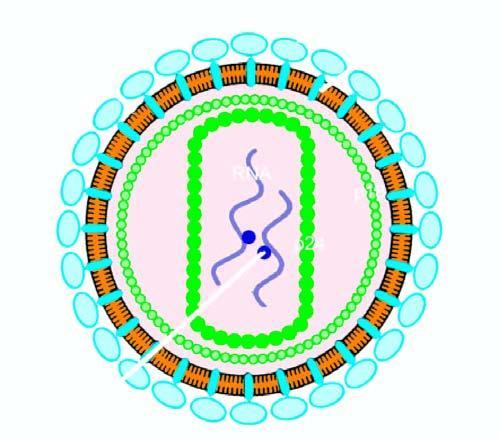the particle has core containing proteins, p24 and p18, how many strands of viral rna, and enzyme reverse transcriptase?
Answer the question using a single word or phrase. Two 